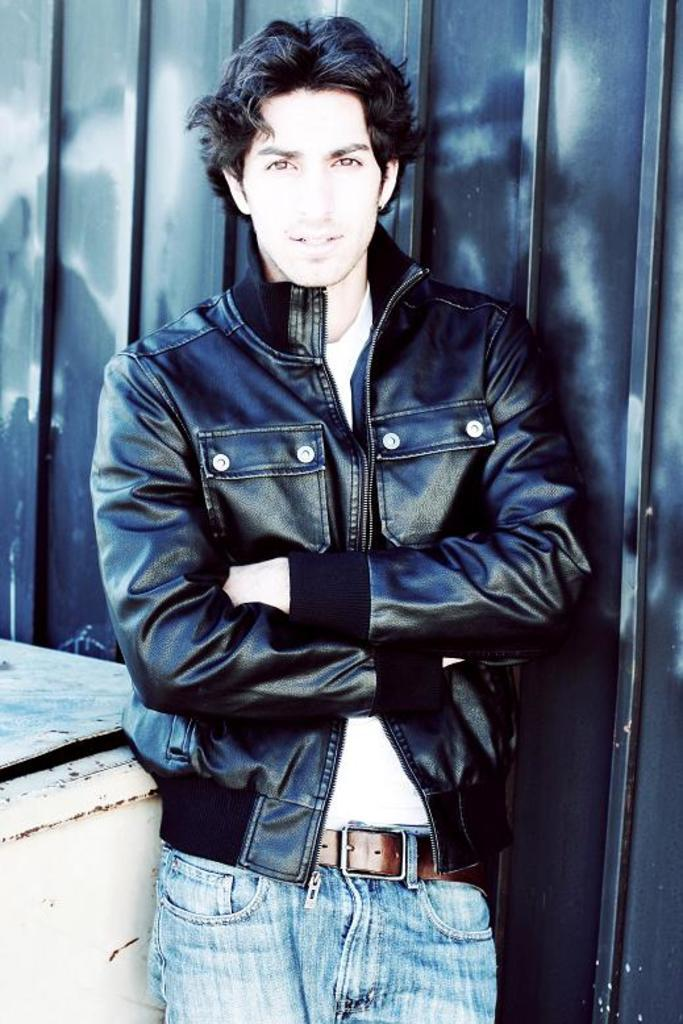Who is present in the image? There is a man in the picture. What is the man wearing in the image? The man is wearing a jacket. Where is the man located in the image? The man is standing near a wall. What type of bit is the man holding in the image? There is no bit present in the image; the man is not holding anything. 